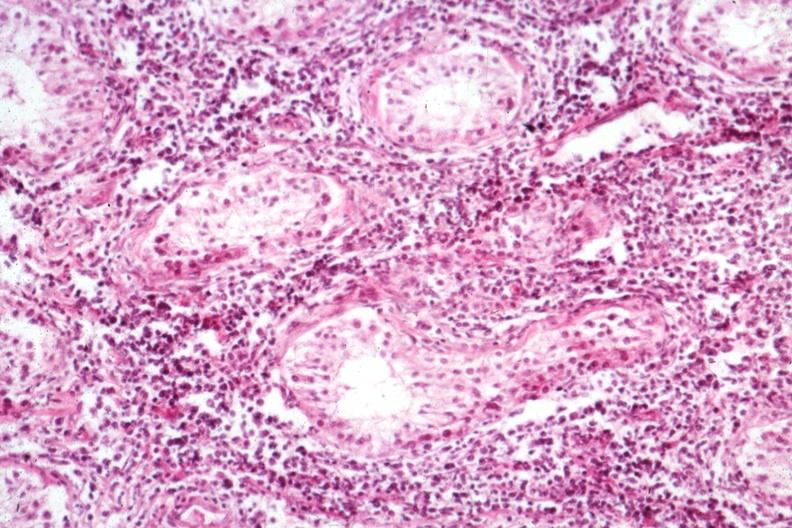s malignant lymphoma present?
Answer the question using a single word or phrase. Yes 